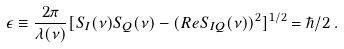<formula> <loc_0><loc_0><loc_500><loc_500>\epsilon \equiv \frac { 2 \pi } { \lambda ( \nu ) } [ S _ { I } ( \nu ) S _ { Q } ( \nu ) - ( R e S _ { I Q } ( \nu ) ) ^ { 2 } ] ^ { 1 / 2 } = \hbar { / } 2 \, .</formula> 